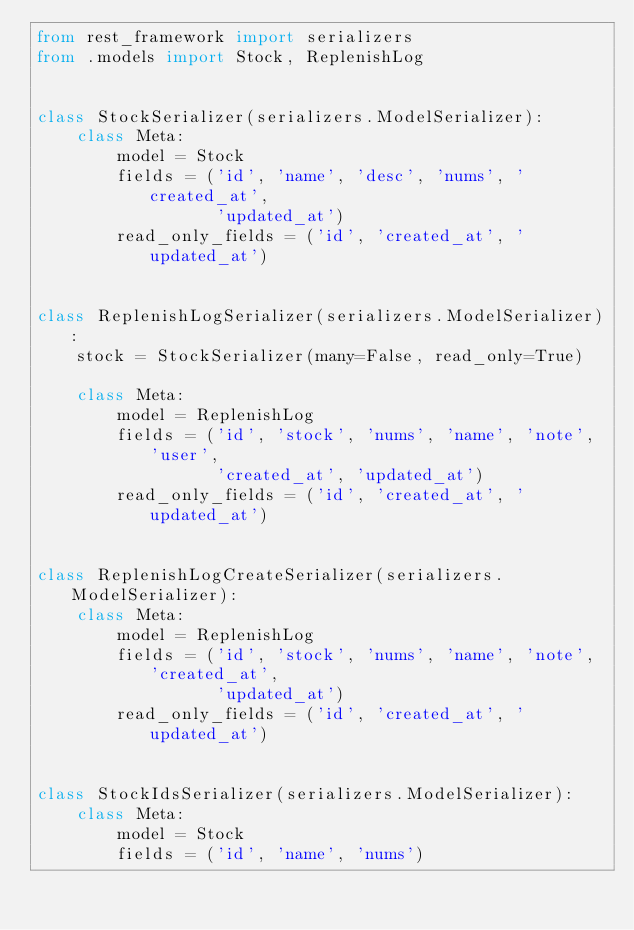Convert code to text. <code><loc_0><loc_0><loc_500><loc_500><_Python_>from rest_framework import serializers
from .models import Stock, ReplenishLog


class StockSerializer(serializers.ModelSerializer):
    class Meta:
        model = Stock
        fields = ('id', 'name', 'desc', 'nums', 'created_at',
                  'updated_at')
        read_only_fields = ('id', 'created_at', 'updated_at')


class ReplenishLogSerializer(serializers.ModelSerializer):
    stock = StockSerializer(many=False, read_only=True)

    class Meta:
        model = ReplenishLog
        fields = ('id', 'stock', 'nums', 'name', 'note', 'user',
                  'created_at', 'updated_at')
        read_only_fields = ('id', 'created_at', 'updated_at')


class ReplenishLogCreateSerializer(serializers.ModelSerializer):
    class Meta:
        model = ReplenishLog
        fields = ('id', 'stock', 'nums', 'name', 'note', 'created_at',
                  'updated_at')
        read_only_fields = ('id', 'created_at', 'updated_at')


class StockIdsSerializer(serializers.ModelSerializer):
    class Meta:
        model = Stock
        fields = ('id', 'name', 'nums')
</code> 